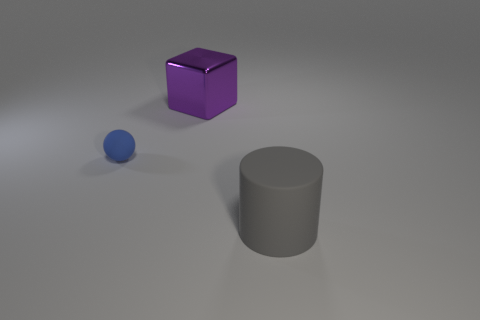There is a thing to the right of the shiny block; is its color the same as the cube?
Your answer should be very brief. No. What number of rubber objects are things or gray cylinders?
Provide a succinct answer. 2. Is there any other thing that has the same size as the sphere?
Your answer should be compact. No. There is a large cylinder that is made of the same material as the small ball; what color is it?
Provide a short and direct response. Gray. How many spheres are either tiny green rubber objects or blue matte things?
Ensure brevity in your answer.  1. How many objects are metallic things or large things that are to the left of the cylinder?
Ensure brevity in your answer.  1. Are any big metal blocks visible?
Your answer should be compact. Yes. There is a matte object that is behind the large object in front of the tiny thing; how big is it?
Provide a short and direct response. Small. Are there any big cylinders that have the same material as the purple object?
Provide a succinct answer. No. There is a gray cylinder that is the same size as the purple shiny object; what material is it?
Offer a terse response. Rubber. 